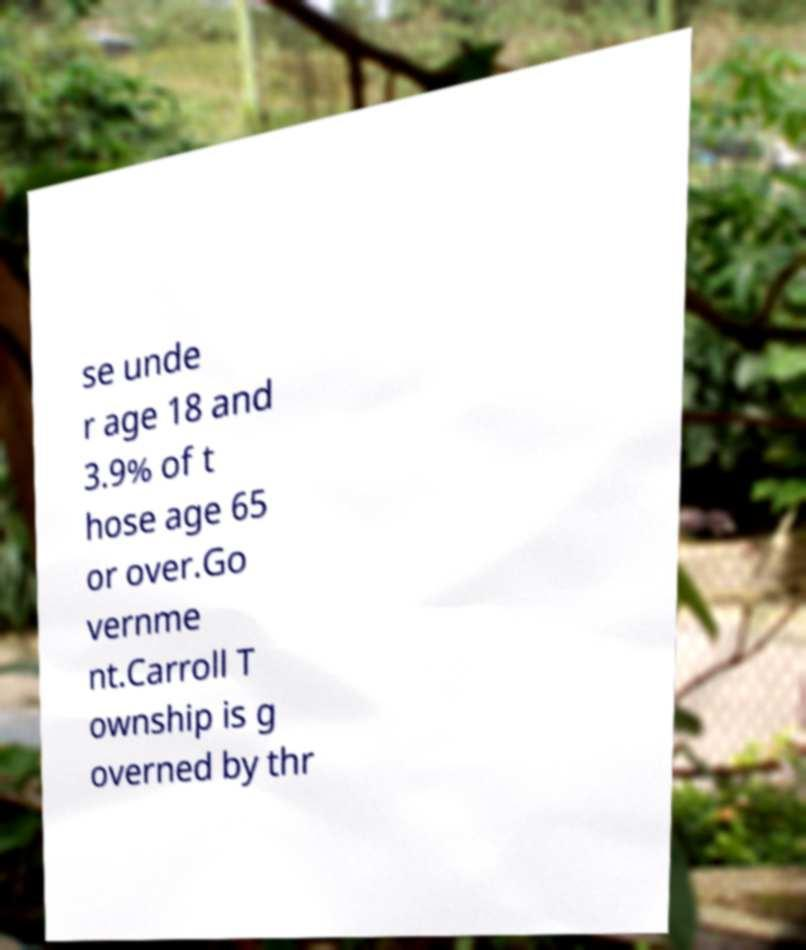Please read and relay the text visible in this image. What does it say? se unde r age 18 and 3.9% of t hose age 65 or over.Go vernme nt.Carroll T ownship is g overned by thr 